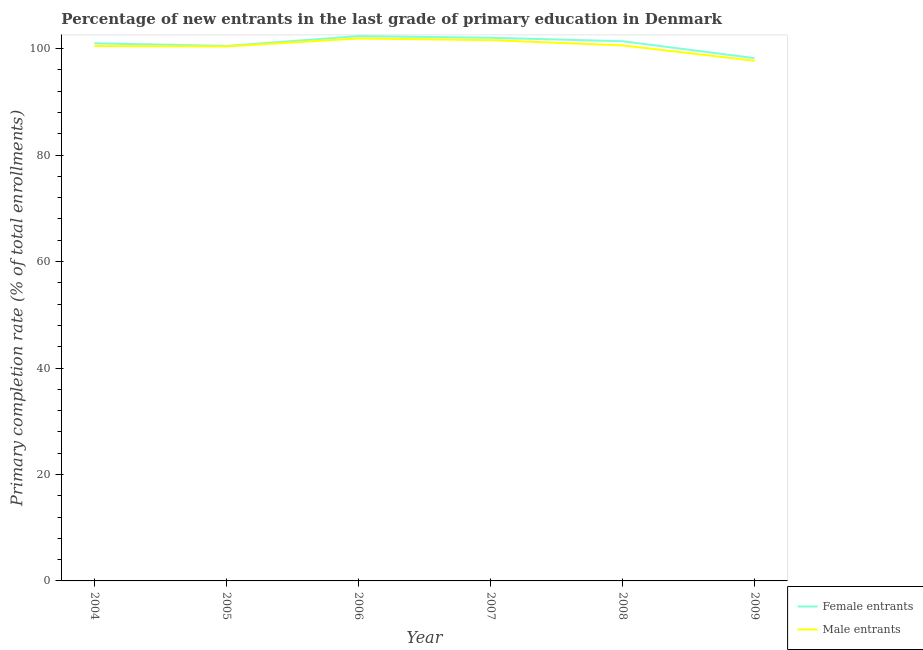What is the primary completion rate of male entrants in 2004?
Provide a short and direct response. 100.49. Across all years, what is the maximum primary completion rate of female entrants?
Make the answer very short. 102.35. Across all years, what is the minimum primary completion rate of male entrants?
Offer a terse response. 97.72. In which year was the primary completion rate of male entrants maximum?
Provide a short and direct response. 2006. What is the total primary completion rate of female entrants in the graph?
Make the answer very short. 605.51. What is the difference between the primary completion rate of male entrants in 2004 and that in 2009?
Keep it short and to the point. 2.77. What is the difference between the primary completion rate of female entrants in 2006 and the primary completion rate of male entrants in 2005?
Provide a succinct answer. 1.95. What is the average primary completion rate of female entrants per year?
Offer a very short reply. 100.92. In the year 2007, what is the difference between the primary completion rate of female entrants and primary completion rate of male entrants?
Offer a terse response. 0.45. In how many years, is the primary completion rate of female entrants greater than 36 %?
Your response must be concise. 6. What is the ratio of the primary completion rate of female entrants in 2005 to that in 2007?
Give a very brief answer. 0.98. Is the difference between the primary completion rate of female entrants in 2007 and 2009 greater than the difference between the primary completion rate of male entrants in 2007 and 2009?
Offer a terse response. No. What is the difference between the highest and the second highest primary completion rate of male entrants?
Ensure brevity in your answer.  0.31. What is the difference between the highest and the lowest primary completion rate of female entrants?
Ensure brevity in your answer.  4.14. Is the primary completion rate of female entrants strictly greater than the primary completion rate of male entrants over the years?
Your response must be concise. Yes. How many lines are there?
Your answer should be very brief. 2. How many years are there in the graph?
Make the answer very short. 6. What is the difference between two consecutive major ticks on the Y-axis?
Your answer should be very brief. 20. How are the legend labels stacked?
Ensure brevity in your answer.  Vertical. What is the title of the graph?
Your response must be concise. Percentage of new entrants in the last grade of primary education in Denmark. What is the label or title of the X-axis?
Your response must be concise. Year. What is the label or title of the Y-axis?
Provide a succinct answer. Primary completion rate (% of total enrollments). What is the Primary completion rate (% of total enrollments) of Female entrants in 2004?
Provide a succinct answer. 101.01. What is the Primary completion rate (% of total enrollments) in Male entrants in 2004?
Your answer should be very brief. 100.49. What is the Primary completion rate (% of total enrollments) of Female entrants in 2005?
Provide a succinct answer. 100.49. What is the Primary completion rate (% of total enrollments) in Male entrants in 2005?
Your response must be concise. 100.41. What is the Primary completion rate (% of total enrollments) of Female entrants in 2006?
Provide a short and direct response. 102.35. What is the Primary completion rate (% of total enrollments) in Male entrants in 2006?
Offer a very short reply. 101.91. What is the Primary completion rate (% of total enrollments) of Female entrants in 2007?
Your response must be concise. 102.05. What is the Primary completion rate (% of total enrollments) in Male entrants in 2007?
Provide a short and direct response. 101.6. What is the Primary completion rate (% of total enrollments) in Female entrants in 2008?
Provide a short and direct response. 101.39. What is the Primary completion rate (% of total enrollments) in Male entrants in 2008?
Make the answer very short. 100.61. What is the Primary completion rate (% of total enrollments) of Female entrants in 2009?
Ensure brevity in your answer.  98.22. What is the Primary completion rate (% of total enrollments) of Male entrants in 2009?
Provide a succinct answer. 97.72. Across all years, what is the maximum Primary completion rate (% of total enrollments) in Female entrants?
Your answer should be very brief. 102.35. Across all years, what is the maximum Primary completion rate (% of total enrollments) of Male entrants?
Provide a succinct answer. 101.91. Across all years, what is the minimum Primary completion rate (% of total enrollments) of Female entrants?
Your response must be concise. 98.22. Across all years, what is the minimum Primary completion rate (% of total enrollments) of Male entrants?
Your response must be concise. 97.72. What is the total Primary completion rate (% of total enrollments) of Female entrants in the graph?
Your answer should be very brief. 605.51. What is the total Primary completion rate (% of total enrollments) in Male entrants in the graph?
Ensure brevity in your answer.  602.73. What is the difference between the Primary completion rate (% of total enrollments) in Female entrants in 2004 and that in 2005?
Offer a very short reply. 0.52. What is the difference between the Primary completion rate (% of total enrollments) in Male entrants in 2004 and that in 2005?
Your response must be concise. 0.08. What is the difference between the Primary completion rate (% of total enrollments) of Female entrants in 2004 and that in 2006?
Your answer should be compact. -1.35. What is the difference between the Primary completion rate (% of total enrollments) of Male entrants in 2004 and that in 2006?
Keep it short and to the point. -1.42. What is the difference between the Primary completion rate (% of total enrollments) of Female entrants in 2004 and that in 2007?
Make the answer very short. -1.04. What is the difference between the Primary completion rate (% of total enrollments) of Male entrants in 2004 and that in 2007?
Make the answer very short. -1.11. What is the difference between the Primary completion rate (% of total enrollments) of Female entrants in 2004 and that in 2008?
Offer a very short reply. -0.38. What is the difference between the Primary completion rate (% of total enrollments) in Male entrants in 2004 and that in 2008?
Give a very brief answer. -0.12. What is the difference between the Primary completion rate (% of total enrollments) in Female entrants in 2004 and that in 2009?
Your response must be concise. 2.79. What is the difference between the Primary completion rate (% of total enrollments) in Male entrants in 2004 and that in 2009?
Offer a very short reply. 2.77. What is the difference between the Primary completion rate (% of total enrollments) of Female entrants in 2005 and that in 2006?
Provide a succinct answer. -1.86. What is the difference between the Primary completion rate (% of total enrollments) of Male entrants in 2005 and that in 2006?
Provide a short and direct response. -1.5. What is the difference between the Primary completion rate (% of total enrollments) in Female entrants in 2005 and that in 2007?
Your response must be concise. -1.55. What is the difference between the Primary completion rate (% of total enrollments) in Male entrants in 2005 and that in 2007?
Your answer should be very brief. -1.19. What is the difference between the Primary completion rate (% of total enrollments) of Female entrants in 2005 and that in 2008?
Keep it short and to the point. -0.9. What is the difference between the Primary completion rate (% of total enrollments) of Male entrants in 2005 and that in 2008?
Offer a very short reply. -0.2. What is the difference between the Primary completion rate (% of total enrollments) in Female entrants in 2005 and that in 2009?
Keep it short and to the point. 2.28. What is the difference between the Primary completion rate (% of total enrollments) in Male entrants in 2005 and that in 2009?
Give a very brief answer. 2.68. What is the difference between the Primary completion rate (% of total enrollments) in Female entrants in 2006 and that in 2007?
Provide a short and direct response. 0.31. What is the difference between the Primary completion rate (% of total enrollments) in Male entrants in 2006 and that in 2007?
Give a very brief answer. 0.31. What is the difference between the Primary completion rate (% of total enrollments) of Female entrants in 2006 and that in 2008?
Ensure brevity in your answer.  0.96. What is the difference between the Primary completion rate (% of total enrollments) in Male entrants in 2006 and that in 2008?
Your response must be concise. 1.3. What is the difference between the Primary completion rate (% of total enrollments) of Female entrants in 2006 and that in 2009?
Your response must be concise. 4.14. What is the difference between the Primary completion rate (% of total enrollments) in Male entrants in 2006 and that in 2009?
Ensure brevity in your answer.  4.19. What is the difference between the Primary completion rate (% of total enrollments) of Female entrants in 2007 and that in 2008?
Provide a succinct answer. 0.65. What is the difference between the Primary completion rate (% of total enrollments) of Female entrants in 2007 and that in 2009?
Make the answer very short. 3.83. What is the difference between the Primary completion rate (% of total enrollments) of Male entrants in 2007 and that in 2009?
Give a very brief answer. 3.87. What is the difference between the Primary completion rate (% of total enrollments) of Female entrants in 2008 and that in 2009?
Your answer should be very brief. 3.17. What is the difference between the Primary completion rate (% of total enrollments) of Male entrants in 2008 and that in 2009?
Your answer should be compact. 2.88. What is the difference between the Primary completion rate (% of total enrollments) in Female entrants in 2004 and the Primary completion rate (% of total enrollments) in Male entrants in 2005?
Offer a terse response. 0.6. What is the difference between the Primary completion rate (% of total enrollments) in Female entrants in 2004 and the Primary completion rate (% of total enrollments) in Male entrants in 2006?
Provide a short and direct response. -0.9. What is the difference between the Primary completion rate (% of total enrollments) of Female entrants in 2004 and the Primary completion rate (% of total enrollments) of Male entrants in 2007?
Give a very brief answer. -0.59. What is the difference between the Primary completion rate (% of total enrollments) of Female entrants in 2004 and the Primary completion rate (% of total enrollments) of Male entrants in 2008?
Your answer should be very brief. 0.4. What is the difference between the Primary completion rate (% of total enrollments) of Female entrants in 2004 and the Primary completion rate (% of total enrollments) of Male entrants in 2009?
Offer a very short reply. 3.29. What is the difference between the Primary completion rate (% of total enrollments) in Female entrants in 2005 and the Primary completion rate (% of total enrollments) in Male entrants in 2006?
Offer a very short reply. -1.42. What is the difference between the Primary completion rate (% of total enrollments) of Female entrants in 2005 and the Primary completion rate (% of total enrollments) of Male entrants in 2007?
Your answer should be very brief. -1.1. What is the difference between the Primary completion rate (% of total enrollments) of Female entrants in 2005 and the Primary completion rate (% of total enrollments) of Male entrants in 2008?
Keep it short and to the point. -0.12. What is the difference between the Primary completion rate (% of total enrollments) in Female entrants in 2005 and the Primary completion rate (% of total enrollments) in Male entrants in 2009?
Keep it short and to the point. 2.77. What is the difference between the Primary completion rate (% of total enrollments) in Female entrants in 2006 and the Primary completion rate (% of total enrollments) in Male entrants in 2007?
Your answer should be very brief. 0.76. What is the difference between the Primary completion rate (% of total enrollments) of Female entrants in 2006 and the Primary completion rate (% of total enrollments) of Male entrants in 2008?
Ensure brevity in your answer.  1.75. What is the difference between the Primary completion rate (% of total enrollments) in Female entrants in 2006 and the Primary completion rate (% of total enrollments) in Male entrants in 2009?
Offer a terse response. 4.63. What is the difference between the Primary completion rate (% of total enrollments) in Female entrants in 2007 and the Primary completion rate (% of total enrollments) in Male entrants in 2008?
Make the answer very short. 1.44. What is the difference between the Primary completion rate (% of total enrollments) of Female entrants in 2007 and the Primary completion rate (% of total enrollments) of Male entrants in 2009?
Give a very brief answer. 4.32. What is the difference between the Primary completion rate (% of total enrollments) in Female entrants in 2008 and the Primary completion rate (% of total enrollments) in Male entrants in 2009?
Offer a very short reply. 3.67. What is the average Primary completion rate (% of total enrollments) of Female entrants per year?
Provide a succinct answer. 100.92. What is the average Primary completion rate (% of total enrollments) of Male entrants per year?
Your answer should be compact. 100.46. In the year 2004, what is the difference between the Primary completion rate (% of total enrollments) in Female entrants and Primary completion rate (% of total enrollments) in Male entrants?
Give a very brief answer. 0.52. In the year 2005, what is the difference between the Primary completion rate (% of total enrollments) of Female entrants and Primary completion rate (% of total enrollments) of Male entrants?
Ensure brevity in your answer.  0.08. In the year 2006, what is the difference between the Primary completion rate (% of total enrollments) in Female entrants and Primary completion rate (% of total enrollments) in Male entrants?
Your response must be concise. 0.44. In the year 2007, what is the difference between the Primary completion rate (% of total enrollments) in Female entrants and Primary completion rate (% of total enrollments) in Male entrants?
Ensure brevity in your answer.  0.45. In the year 2008, what is the difference between the Primary completion rate (% of total enrollments) in Female entrants and Primary completion rate (% of total enrollments) in Male entrants?
Provide a succinct answer. 0.78. In the year 2009, what is the difference between the Primary completion rate (% of total enrollments) of Female entrants and Primary completion rate (% of total enrollments) of Male entrants?
Your answer should be very brief. 0.49. What is the ratio of the Primary completion rate (% of total enrollments) in Female entrants in 2004 to that in 2006?
Keep it short and to the point. 0.99. What is the ratio of the Primary completion rate (% of total enrollments) of Male entrants in 2004 to that in 2006?
Offer a terse response. 0.99. What is the ratio of the Primary completion rate (% of total enrollments) of Female entrants in 2004 to that in 2008?
Provide a succinct answer. 1. What is the ratio of the Primary completion rate (% of total enrollments) of Male entrants in 2004 to that in 2008?
Your response must be concise. 1. What is the ratio of the Primary completion rate (% of total enrollments) in Female entrants in 2004 to that in 2009?
Give a very brief answer. 1.03. What is the ratio of the Primary completion rate (% of total enrollments) in Male entrants in 2004 to that in 2009?
Your answer should be very brief. 1.03. What is the ratio of the Primary completion rate (% of total enrollments) of Female entrants in 2005 to that in 2006?
Keep it short and to the point. 0.98. What is the ratio of the Primary completion rate (% of total enrollments) in Male entrants in 2005 to that in 2006?
Your answer should be very brief. 0.99. What is the ratio of the Primary completion rate (% of total enrollments) in Male entrants in 2005 to that in 2007?
Your answer should be very brief. 0.99. What is the ratio of the Primary completion rate (% of total enrollments) in Female entrants in 2005 to that in 2008?
Ensure brevity in your answer.  0.99. What is the ratio of the Primary completion rate (% of total enrollments) of Female entrants in 2005 to that in 2009?
Make the answer very short. 1.02. What is the ratio of the Primary completion rate (% of total enrollments) of Male entrants in 2005 to that in 2009?
Provide a succinct answer. 1.03. What is the ratio of the Primary completion rate (% of total enrollments) of Female entrants in 2006 to that in 2007?
Your answer should be compact. 1. What is the ratio of the Primary completion rate (% of total enrollments) of Female entrants in 2006 to that in 2008?
Offer a terse response. 1.01. What is the ratio of the Primary completion rate (% of total enrollments) of Male entrants in 2006 to that in 2008?
Offer a terse response. 1.01. What is the ratio of the Primary completion rate (% of total enrollments) in Female entrants in 2006 to that in 2009?
Provide a succinct answer. 1.04. What is the ratio of the Primary completion rate (% of total enrollments) in Male entrants in 2006 to that in 2009?
Your answer should be compact. 1.04. What is the ratio of the Primary completion rate (% of total enrollments) of Female entrants in 2007 to that in 2008?
Your answer should be very brief. 1.01. What is the ratio of the Primary completion rate (% of total enrollments) in Male entrants in 2007 to that in 2008?
Give a very brief answer. 1.01. What is the ratio of the Primary completion rate (% of total enrollments) of Female entrants in 2007 to that in 2009?
Your response must be concise. 1.04. What is the ratio of the Primary completion rate (% of total enrollments) of Male entrants in 2007 to that in 2009?
Keep it short and to the point. 1.04. What is the ratio of the Primary completion rate (% of total enrollments) in Female entrants in 2008 to that in 2009?
Make the answer very short. 1.03. What is the ratio of the Primary completion rate (% of total enrollments) in Male entrants in 2008 to that in 2009?
Keep it short and to the point. 1.03. What is the difference between the highest and the second highest Primary completion rate (% of total enrollments) in Female entrants?
Provide a short and direct response. 0.31. What is the difference between the highest and the second highest Primary completion rate (% of total enrollments) in Male entrants?
Keep it short and to the point. 0.31. What is the difference between the highest and the lowest Primary completion rate (% of total enrollments) of Female entrants?
Your response must be concise. 4.14. What is the difference between the highest and the lowest Primary completion rate (% of total enrollments) of Male entrants?
Your response must be concise. 4.19. 